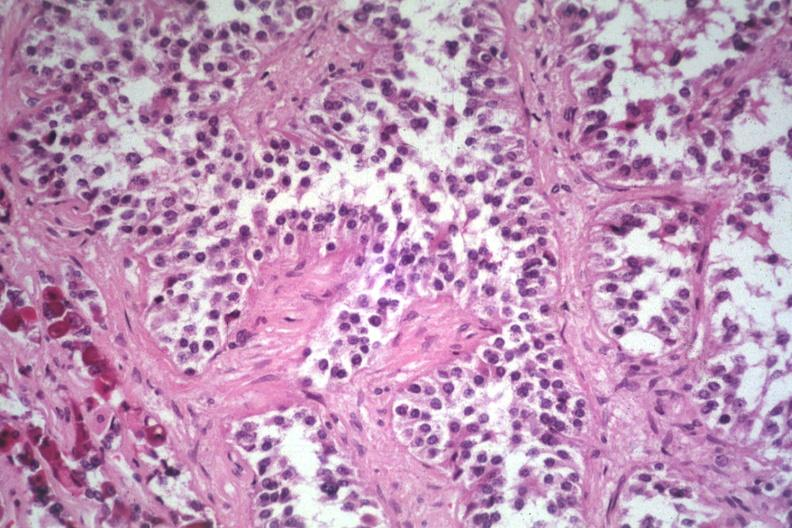what is present?
Answer the question using a single word or phrase. Endocrine 